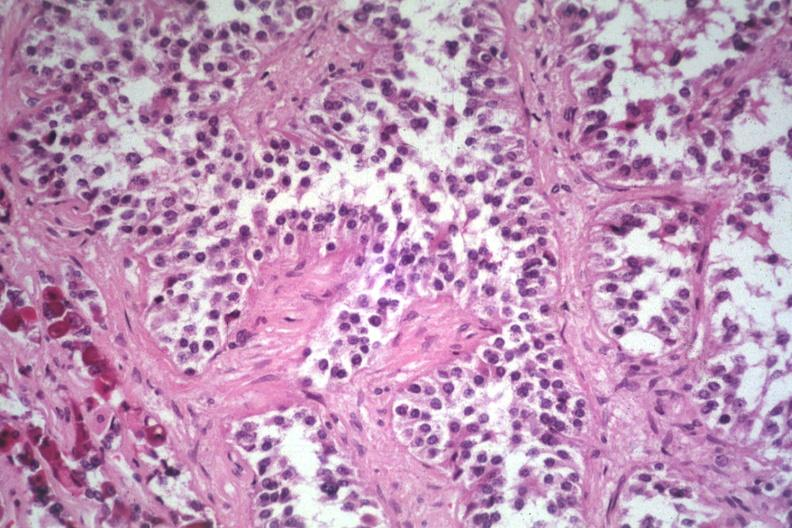what is present?
Answer the question using a single word or phrase. Endocrine 